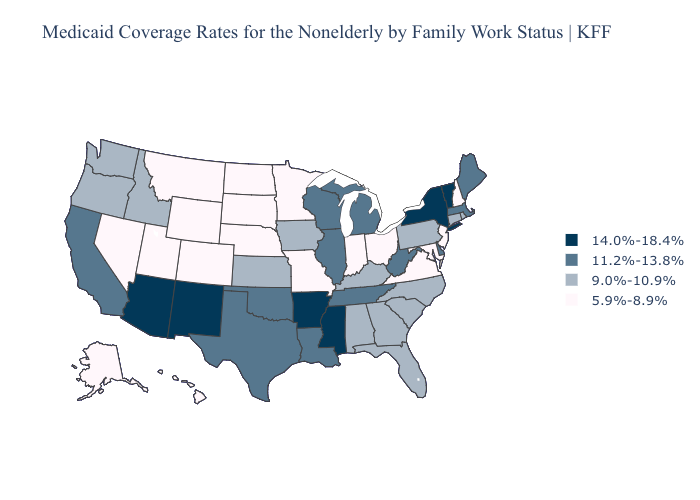Name the states that have a value in the range 11.2%-13.8%?
Be succinct. California, Delaware, Illinois, Louisiana, Maine, Massachusetts, Michigan, Oklahoma, Tennessee, Texas, West Virginia, Wisconsin. How many symbols are there in the legend?
Answer briefly. 4. Does Washington have the lowest value in the USA?
Write a very short answer. No. Which states have the lowest value in the West?
Give a very brief answer. Alaska, Colorado, Hawaii, Montana, Nevada, Utah, Wyoming. Does Illinois have a higher value than Michigan?
Give a very brief answer. No. Name the states that have a value in the range 11.2%-13.8%?
Concise answer only. California, Delaware, Illinois, Louisiana, Maine, Massachusetts, Michigan, Oklahoma, Tennessee, Texas, West Virginia, Wisconsin. Does New Hampshire have the lowest value in the USA?
Answer briefly. Yes. Does Oregon have a higher value than Ohio?
Short answer required. Yes. Among the states that border California , does Oregon have the highest value?
Answer briefly. No. What is the lowest value in the USA?
Give a very brief answer. 5.9%-8.9%. What is the value of New York?
Concise answer only. 14.0%-18.4%. What is the lowest value in the Northeast?
Keep it brief. 5.9%-8.9%. Does Hawaii have a higher value than Maryland?
Short answer required. No. Does New York have the highest value in the USA?
Concise answer only. Yes. Which states have the lowest value in the Northeast?
Write a very short answer. New Hampshire, New Jersey. 